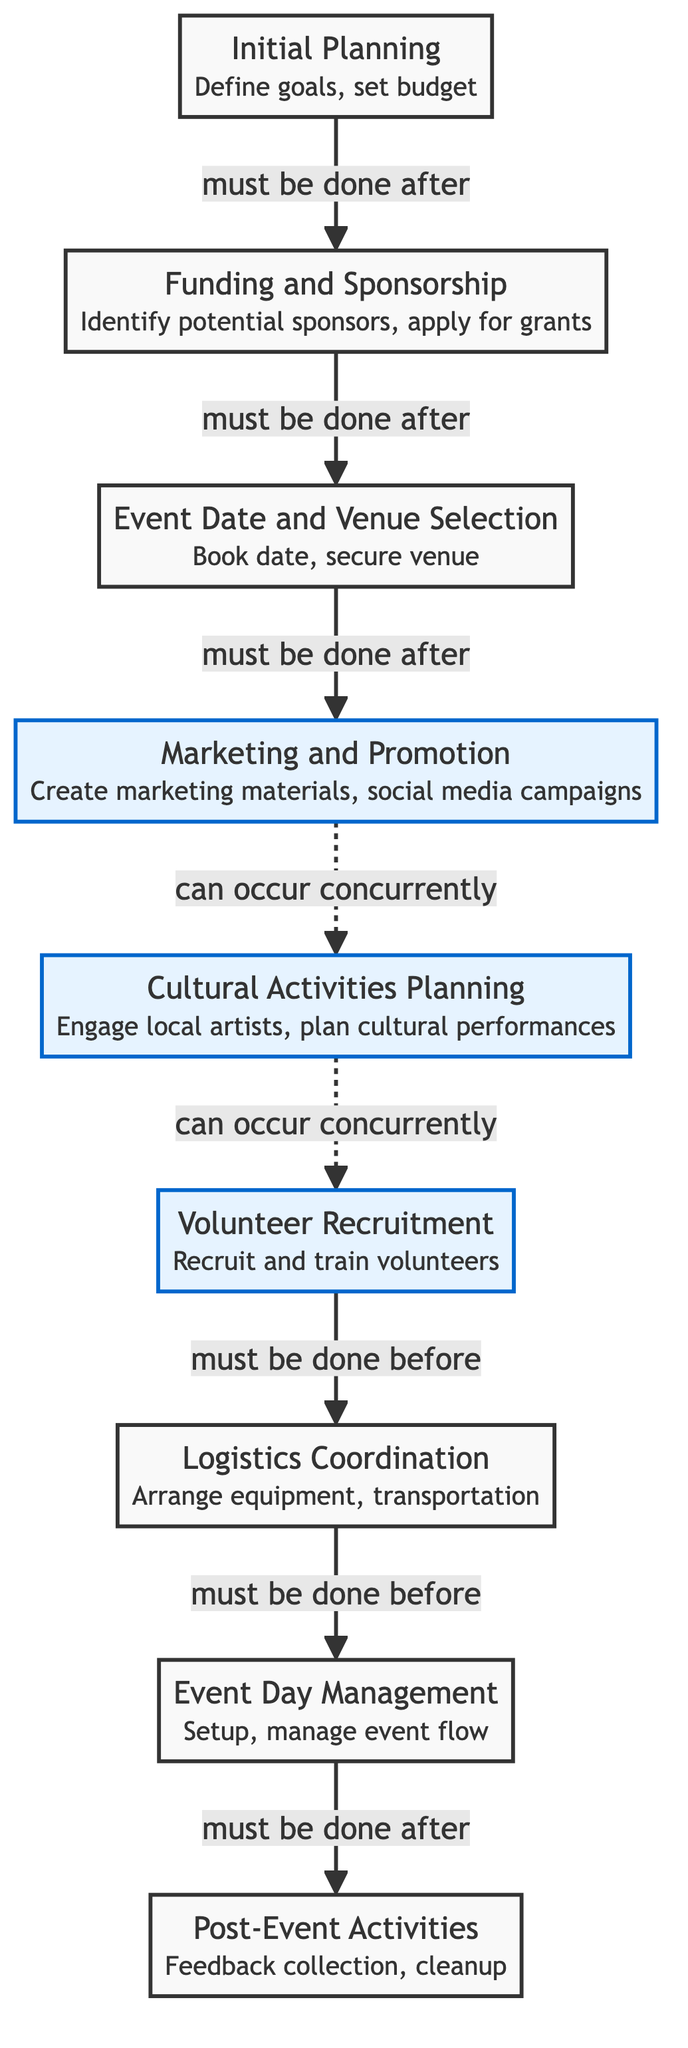What is the first step in the event planning process? The diagram indicates that the first step is "Initial Planning," which includes defining goals and setting a budget. This is the starting point for the event planning process.
Answer: Initial Planning How many main steps are there in the checklist? By counting the numbered nodes in the diagram, I see there are a total of nine main steps listed.
Answer: Nine Which step must occur after securing the event date and venue? The diagram shows that "Marketing and Promotion" must occur after "Event Date and Venue Selection." This means that once the date and venue are secured, the next step is marketing.
Answer: Marketing and Promotion What steps can occur concurrently with cultural activities planning? According to the diagram, both "Marketing and Promotion" and "Volunteer Recruitment" can occur concurrently with "Cultural Activities Planning." This indicates that these activities can happen simultaneously.
Answer: Marketing and Promotion, Volunteer Recruitment Which step requires volunteer recruitment to be completed before it can begin? The diagram indicates that "Logistics Coordination" must be started after "Volunteer Recruitment." This means that logistics cannot be coordinated until the volunteers are recruited and trained.
Answer: Logistics Coordination What happens after the event day management step? The diagram specifies that after "Event Day Management," the step "Post-Event Activities," including feedback collection and cleanup, must take place. This outlines the order of operations.
Answer: Post-Event Activities What is the primary focus of the second step in the checklist? The second step, "Funding and Sponsorship," focuses on identifying potential sponsors and applying for grants. This is essential for securing financial resources for the event.
Answer: Identify potential sponsors, apply for grants What is the relationship between the marketing and cultural activities planning steps? The diagram illustrates that while "Marketing and Promotion" and "Cultural Activities Planning" can occur concurrently, "Marketing and Promotion" must follow "Event Date and Venue Selection." This establishes their respective positions in the sequence.
Answer: Can occur concurrently How does the checklist ensure a smooth event flow on the event day? The diagram shows that each preceding step must be completed before the "Event Day Management" step, ensuring that all preparations, such as volunteer training and logistics, are in place prior to managing the event.
Answer: All preceding steps must be completed beforehand 